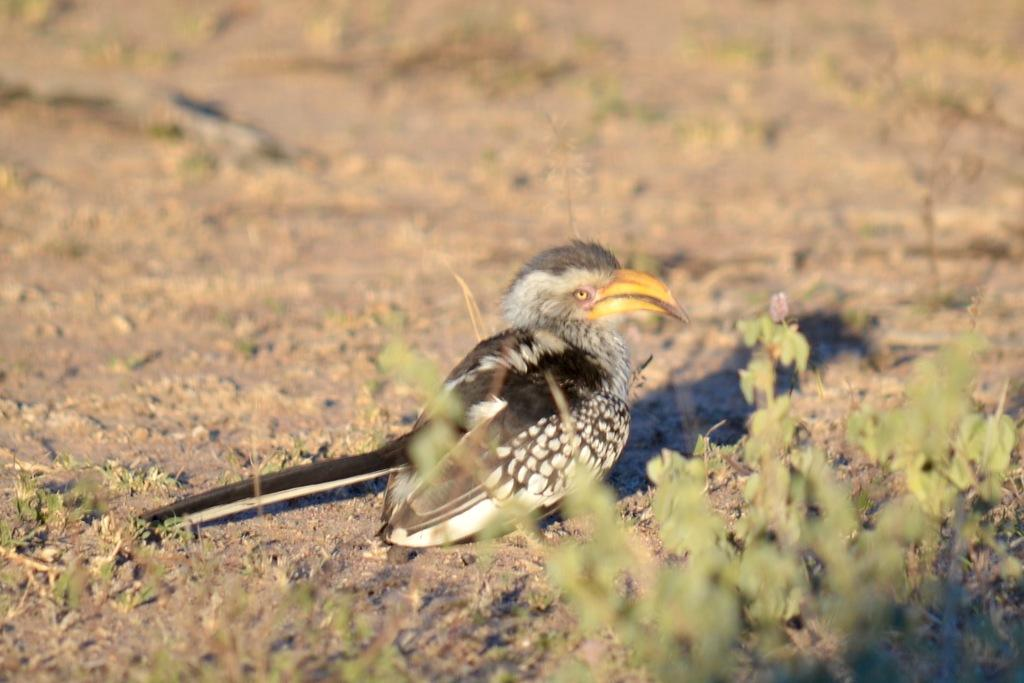What is the main subject in the center of the image? There is a plant in the center of the image. What other living creature can be seen in the image? There is a bird in the image. What color scheme is used for the bird? The bird is in black and white color. What type of branch is the bird holding in its beak in the image? There is no branch visible in the image, and the bird is not holding anything in its beak. 